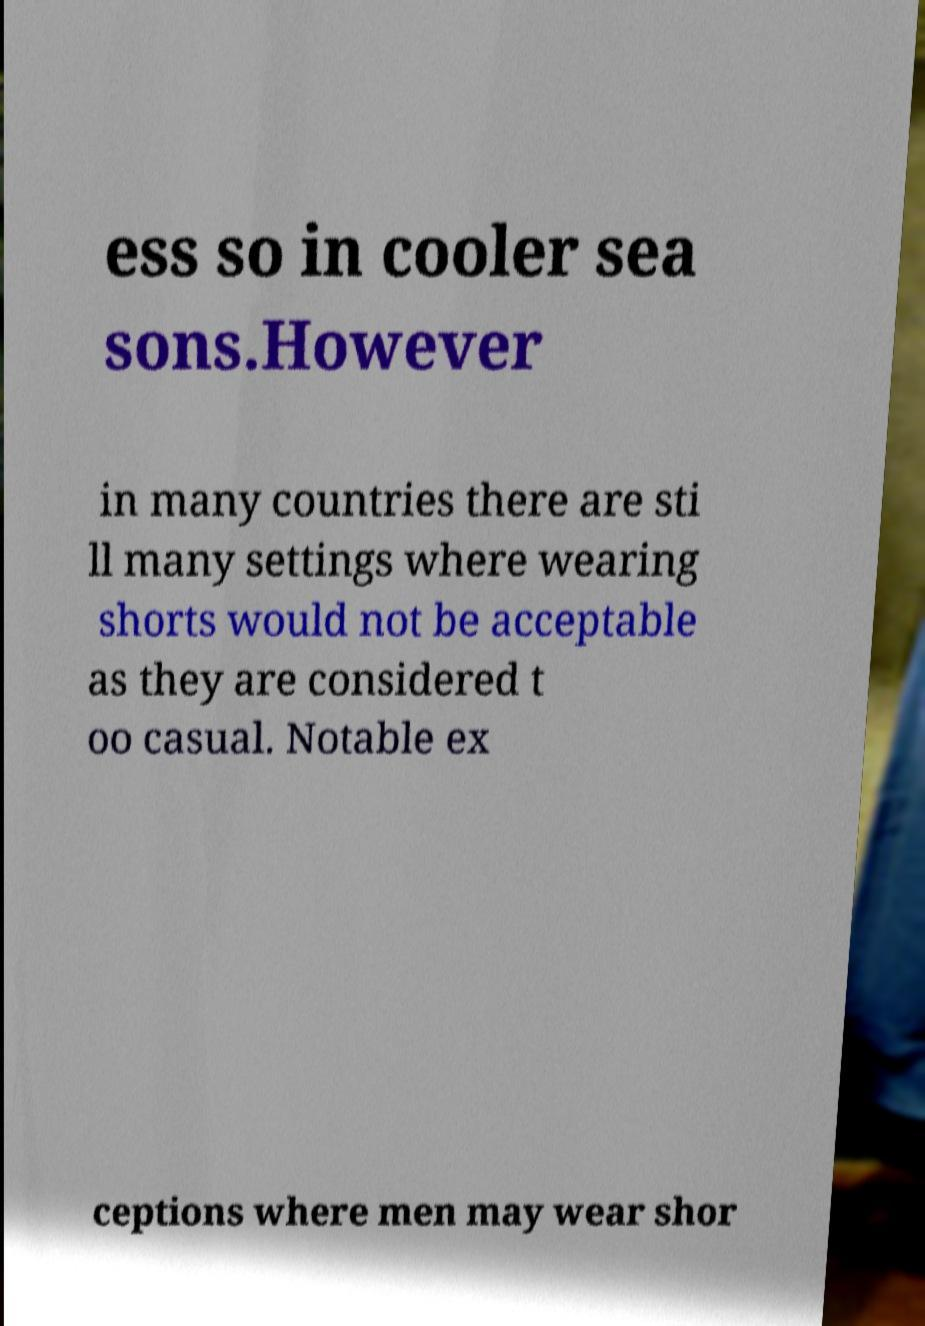Can you accurately transcribe the text from the provided image for me? ess so in cooler sea sons.However in many countries there are sti ll many settings where wearing shorts would not be acceptable as they are considered t oo casual. Notable ex ceptions where men may wear shor 